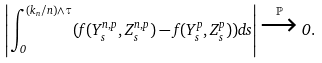Convert formula to latex. <formula><loc_0><loc_0><loc_500><loc_500>\left | \int _ { 0 } ^ { ( k _ { n } / n ) \wedge \tau } ( f ( Y ^ { n , p } _ { s } , Z ^ { n , p } _ { s } ) - f ( Y ^ { p } _ { s } , Z ^ { p } _ { s } ) ) d s \right | \xrightarrow { \mathbb { P } } 0 .</formula> 